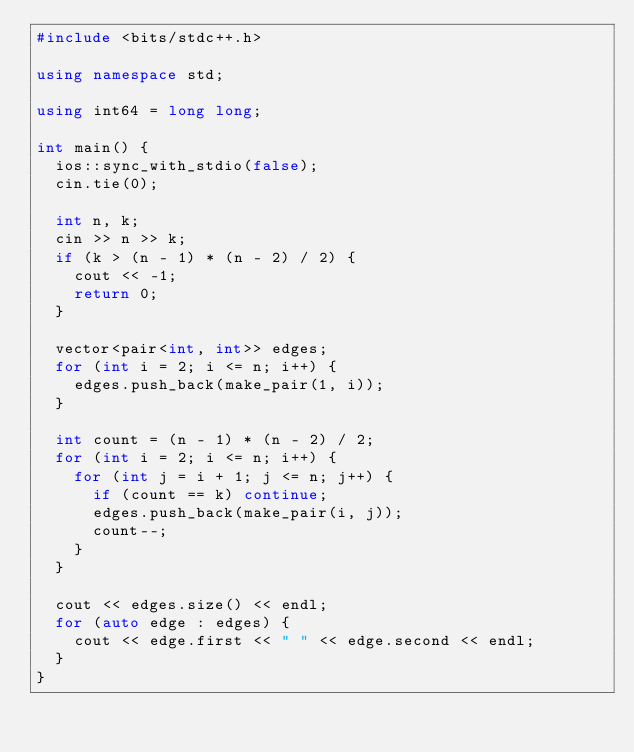Convert code to text. <code><loc_0><loc_0><loc_500><loc_500><_C++_>#include <bits/stdc++.h>

using namespace std;

using int64 = long long;

int main() {
  ios::sync_with_stdio(false);
  cin.tie(0);

  int n, k;
  cin >> n >> k;
  if (k > (n - 1) * (n - 2) / 2) {
    cout << -1;
    return 0;
  }

  vector<pair<int, int>> edges;
  for (int i = 2; i <= n; i++) {
    edges.push_back(make_pair(1, i));
  }

  int count = (n - 1) * (n - 2) / 2;
  for (int i = 2; i <= n; i++) {
    for (int j = i + 1; j <= n; j++) {
      if (count == k) continue;
      edges.push_back(make_pair(i, j));
      count--;
    }
  }

  cout << edges.size() << endl;
  for (auto edge : edges) {
    cout << edge.first << " " << edge.second << endl;
  }
}
</code> 